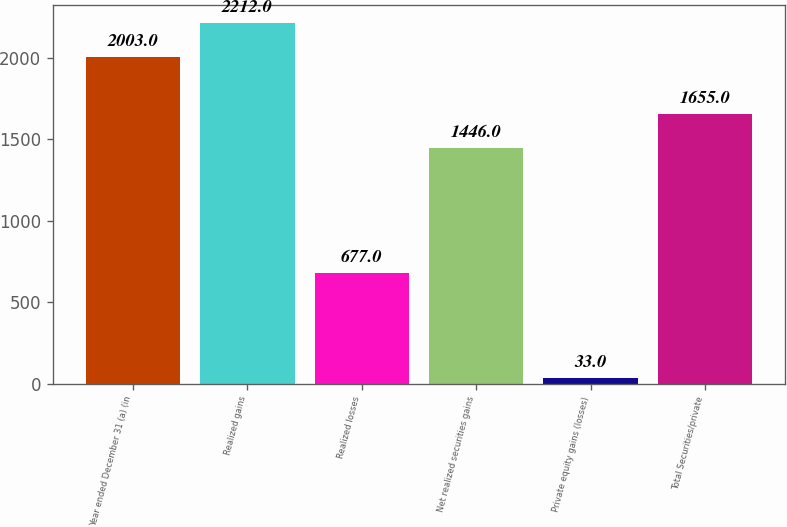<chart> <loc_0><loc_0><loc_500><loc_500><bar_chart><fcel>Year ended December 31 (a) (in<fcel>Realized gains<fcel>Realized losses<fcel>Net realized securities gains<fcel>Private equity gains (losses)<fcel>Total Securities/private<nl><fcel>2003<fcel>2212<fcel>677<fcel>1446<fcel>33<fcel>1655<nl></chart> 